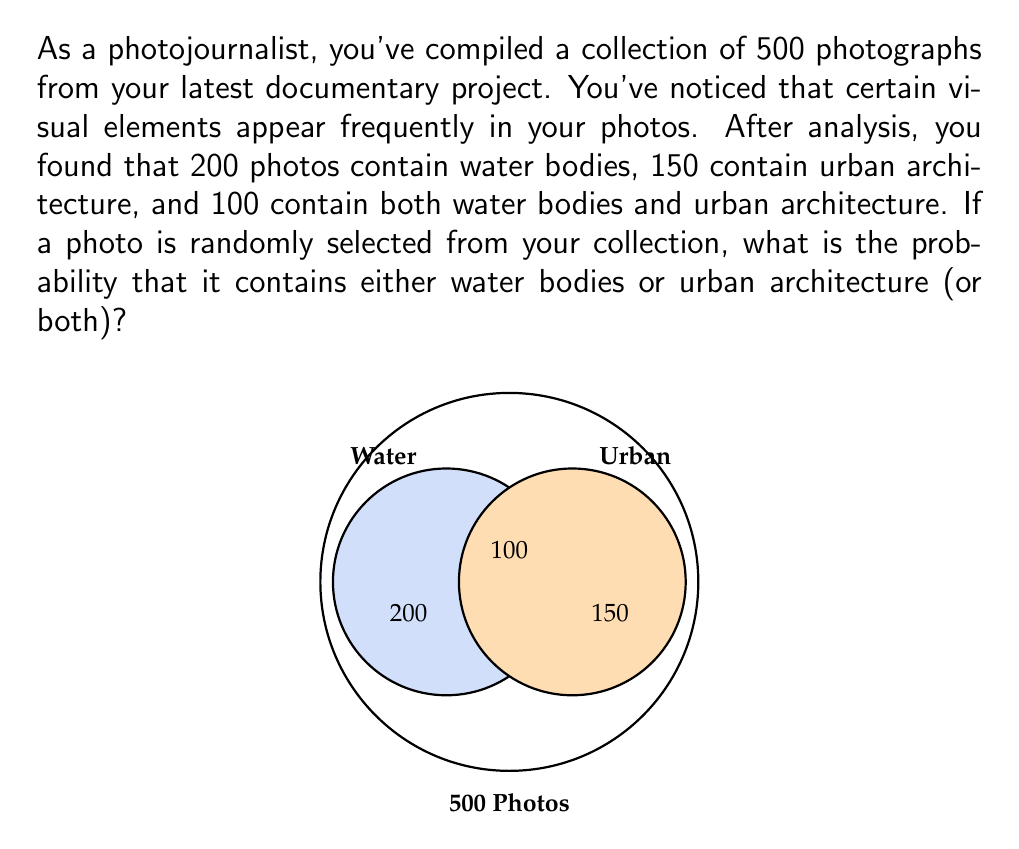Could you help me with this problem? Let's approach this step-by-step using the concept of probability and set theory:

1) Let W be the event that a photo contains water bodies, and U be the event that a photo contains urban architecture.

2) We're asked to find P(W ∪ U), the probability of a photo containing either water bodies or urban architecture (or both).

3) We can use the addition rule of probability:
   
   P(W ∪ U) = P(W) + P(U) - P(W ∩ U)

4) Calculate each probability:
   
   P(W) = 200/500 = 0.4
   P(U) = 150/500 = 0.3
   P(W ∩ U) = 100/500 = 0.2

5) Now, let's substitute these values into our equation:

   P(W ∪ U) = 0.4 + 0.3 - 0.2 = 0.5

6) Therefore, the probability of randomly selecting a photo that contains either water bodies or urban architecture (or both) is 0.5 or 50%.

7) We can verify this result:
   Total photos with water or urban = 200 + 150 - 100 = 250
   (We subtract 100 to avoid double-counting)
   
   250/500 = 0.5, which confirms our calculation.
Answer: 0.5 